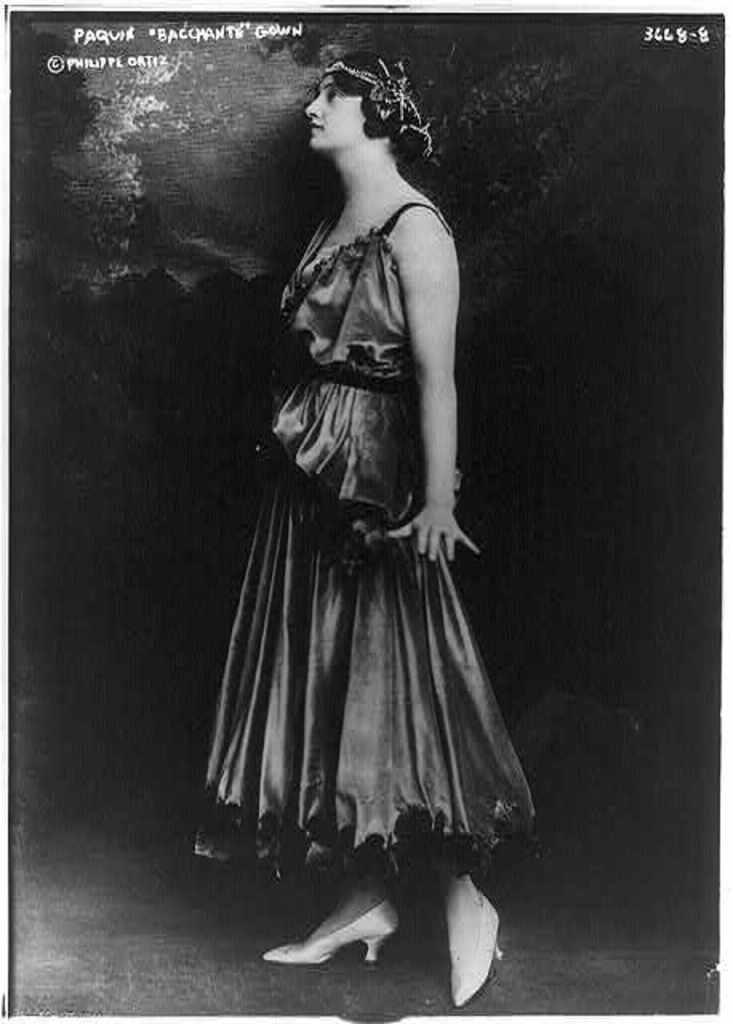What type of visual content is depicted in the image? The image appears to be a poster. Who is featured in the image? There is a woman in the image. What is the woman wearing? The woman is wearing a dress and shoes. How would you describe the background of the image? The background of the image is dark. Are there any additional features on the poster? Yes, there are watermarks on the top of the image. What type of soda is being advertised on the poster? There is no soda being advertised on the poster; it features a woman wearing a dress and shoes. Can you tell me how many porters are visible in the image? There are no porters present in the image; it features a woman in a dark background with watermarks on the top. 